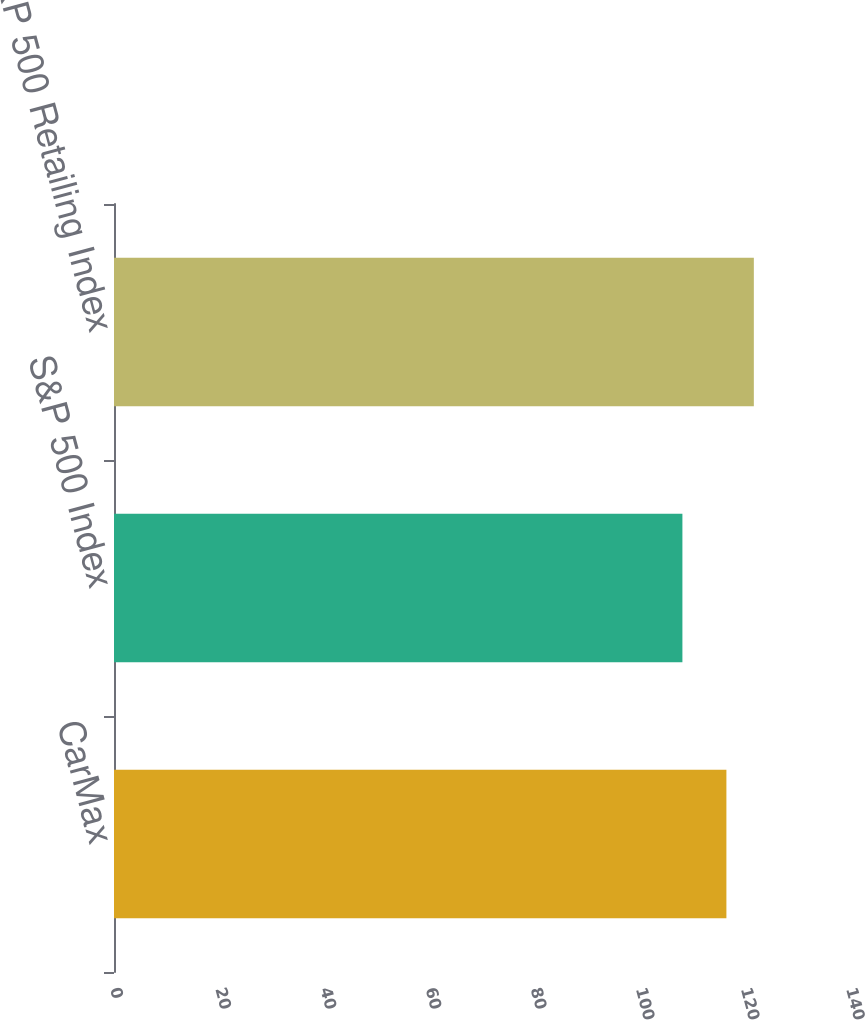<chart> <loc_0><loc_0><loc_500><loc_500><bar_chart><fcel>CarMax<fcel>S&P 500 Index<fcel>S&P 500 Retailing Index<nl><fcel>116.49<fcel>108.12<fcel>121.71<nl></chart> 